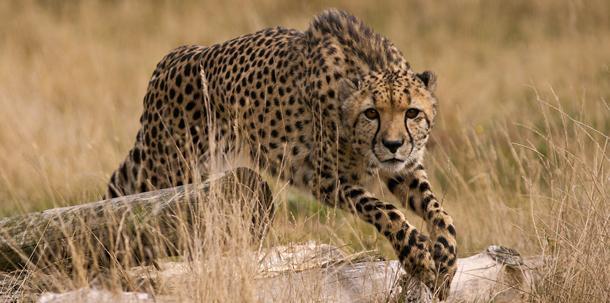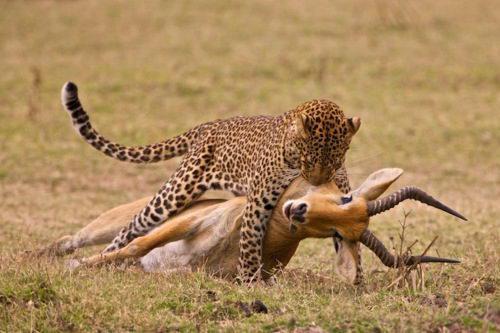The first image is the image on the left, the second image is the image on the right. For the images shown, is this caption "In one image there is a single cheetah and in the other there is a single cheetah successfully hunting an antelope." true? Answer yes or no. Yes. The first image is the image on the left, the second image is the image on the right. For the images displayed, is the sentence "One cheetah is capturing a gazelle in the right image, and the left image contains just one cheetah and no prey animal." factually correct? Answer yes or no. Yes. 